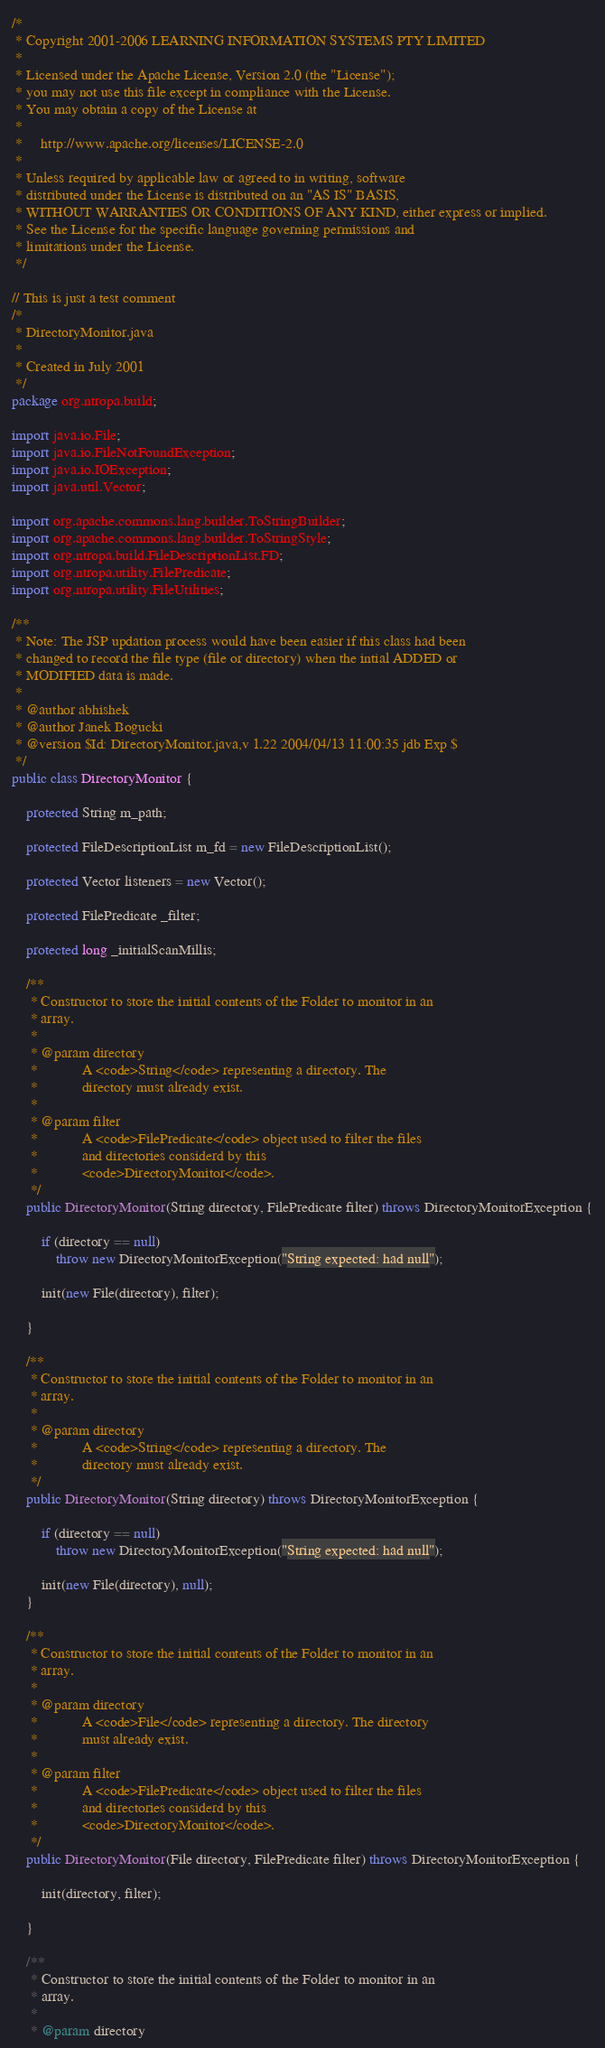<code> <loc_0><loc_0><loc_500><loc_500><_Java_>/*
 * Copyright 2001-2006 LEARNING INFORMATION SYSTEMS PTY LIMITED
 *
 * Licensed under the Apache License, Version 2.0 (the "License");
 * you may not use this file except in compliance with the License.
 * You may obtain a copy of the License at
 *
 *     http://www.apache.org/licenses/LICENSE-2.0
 *
 * Unless required by applicable law or agreed to in writing, software
 * distributed under the License is distributed on an "AS IS" BASIS,
 * WITHOUT WARRANTIES OR CONDITIONS OF ANY KIND, either express or implied.
 * See the License for the specific language governing permissions and
 * limitations under the License.
 */

// This is just a test comment
/*
 * DirectoryMonitor.java
 *
 * Created in July 2001
 */
package org.ntropa.build;

import java.io.File;
import java.io.FileNotFoundException;
import java.io.IOException;
import java.util.Vector;

import org.apache.commons.lang.builder.ToStringBuilder;
import org.apache.commons.lang.builder.ToStringStyle;
import org.ntropa.build.FileDescriptionList.FD;
import org.ntropa.utility.FilePredicate;
import org.ntropa.utility.FileUtilities;

/**
 * Note: The JSP updation process would have been easier if this class had been
 * changed to record the file type (file or directory) when the intial ADDED or
 * MODIFIED data is made.
 * 
 * @author abhishek
 * @author Janek Bogucki
 * @version $Id: DirectoryMonitor.java,v 1.22 2004/04/13 11:00:35 jdb Exp $
 */
public class DirectoryMonitor {

    protected String m_path;

    protected FileDescriptionList m_fd = new FileDescriptionList();

    protected Vector listeners = new Vector();

    protected FilePredicate _filter;

    protected long _initialScanMillis;

    /**
     * Constructor to store the initial contents of the Folder to monitor in an
     * array.
     * 
     * @param directory
     *            A <code>String</code> representing a directory. The
     *            directory must already exist.
     * 
     * @param filter
     *            A <code>FilePredicate</code> object used to filter the files
     *            and directories considerd by this
     *            <code>DirectoryMonitor</code>.
     */
    public DirectoryMonitor(String directory, FilePredicate filter) throws DirectoryMonitorException {

        if (directory == null)
            throw new DirectoryMonitorException("String expected: had null");

        init(new File(directory), filter);

    }

    /**
     * Constructor to store the initial contents of the Folder to monitor in an
     * array.
     * 
     * @param directory
     *            A <code>String</code> representing a directory. The
     *            directory must already exist.
     */
    public DirectoryMonitor(String directory) throws DirectoryMonitorException {

        if (directory == null)
            throw new DirectoryMonitorException("String expected: had null");

        init(new File(directory), null);
    }

    /**
     * Constructor to store the initial contents of the Folder to monitor in an
     * array.
     * 
     * @param directory
     *            A <code>File</code> representing a directory. The directory
     *            must already exist.
     * 
     * @param filter
     *            A <code>FilePredicate</code> object used to filter the files
     *            and directories considerd by this
     *            <code>DirectoryMonitor</code>.
     */
    public DirectoryMonitor(File directory, FilePredicate filter) throws DirectoryMonitorException {

        init(directory, filter);

    }

    /**
     * Constructor to store the initial contents of the Folder to monitor in an
     * array.
     * 
     * @param directory</code> 